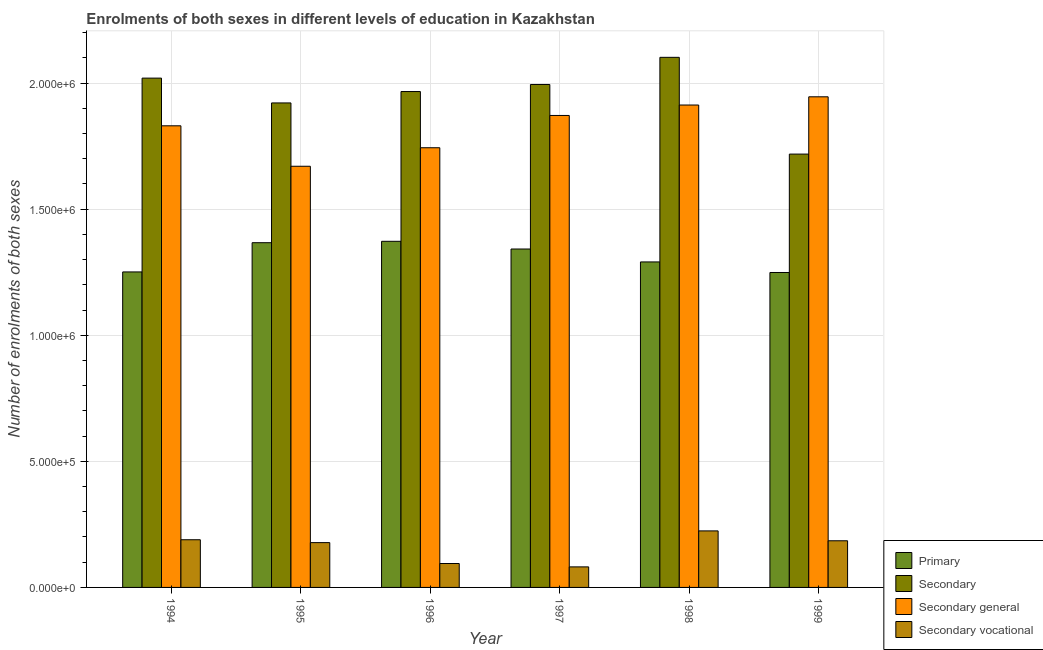How many different coloured bars are there?
Make the answer very short. 4. How many groups of bars are there?
Provide a succinct answer. 6. Are the number of bars per tick equal to the number of legend labels?
Provide a succinct answer. Yes. How many bars are there on the 6th tick from the right?
Your response must be concise. 4. What is the label of the 4th group of bars from the left?
Give a very brief answer. 1997. What is the number of enrolments in secondary general education in 1998?
Your response must be concise. 1.91e+06. Across all years, what is the maximum number of enrolments in primary education?
Provide a succinct answer. 1.37e+06. Across all years, what is the minimum number of enrolments in secondary vocational education?
Your response must be concise. 8.15e+04. What is the total number of enrolments in secondary general education in the graph?
Give a very brief answer. 1.10e+07. What is the difference between the number of enrolments in secondary education in 1994 and that in 1996?
Make the answer very short. 5.32e+04. What is the difference between the number of enrolments in secondary general education in 1998 and the number of enrolments in secondary education in 1996?
Your response must be concise. 1.69e+05. What is the average number of enrolments in secondary vocational education per year?
Your answer should be very brief. 1.59e+05. What is the ratio of the number of enrolments in secondary vocational education in 1994 to that in 1997?
Your answer should be very brief. 2.32. Is the number of enrolments in primary education in 1994 less than that in 1999?
Provide a short and direct response. No. What is the difference between the highest and the second highest number of enrolments in secondary education?
Provide a short and direct response. 8.25e+04. What is the difference between the highest and the lowest number of enrolments in primary education?
Your answer should be compact. 1.24e+05. In how many years, is the number of enrolments in secondary general education greater than the average number of enrolments in secondary general education taken over all years?
Your answer should be compact. 4. Is the sum of the number of enrolments in secondary general education in 1995 and 1998 greater than the maximum number of enrolments in primary education across all years?
Offer a very short reply. Yes. Is it the case that in every year, the sum of the number of enrolments in secondary education and number of enrolments in primary education is greater than the sum of number of enrolments in secondary vocational education and number of enrolments in secondary general education?
Provide a succinct answer. No. What does the 4th bar from the left in 1994 represents?
Your answer should be compact. Secondary vocational. What does the 3rd bar from the right in 1997 represents?
Provide a succinct answer. Secondary. Is it the case that in every year, the sum of the number of enrolments in primary education and number of enrolments in secondary education is greater than the number of enrolments in secondary general education?
Your answer should be very brief. Yes. How many bars are there?
Ensure brevity in your answer.  24. Are all the bars in the graph horizontal?
Provide a short and direct response. No. Does the graph contain any zero values?
Give a very brief answer. No. How many legend labels are there?
Provide a succinct answer. 4. How are the legend labels stacked?
Provide a short and direct response. Vertical. What is the title of the graph?
Ensure brevity in your answer.  Enrolments of both sexes in different levels of education in Kazakhstan. What is the label or title of the Y-axis?
Your answer should be compact. Number of enrolments of both sexes. What is the Number of enrolments of both sexes of Primary in 1994?
Keep it short and to the point. 1.25e+06. What is the Number of enrolments of both sexes in Secondary in 1994?
Your answer should be compact. 2.02e+06. What is the Number of enrolments of both sexes in Secondary general in 1994?
Make the answer very short. 1.83e+06. What is the Number of enrolments of both sexes of Secondary vocational in 1994?
Make the answer very short. 1.89e+05. What is the Number of enrolments of both sexes of Primary in 1995?
Make the answer very short. 1.37e+06. What is the Number of enrolments of both sexes of Secondary in 1995?
Your answer should be compact. 1.92e+06. What is the Number of enrolments of both sexes of Secondary general in 1995?
Ensure brevity in your answer.  1.67e+06. What is the Number of enrolments of both sexes in Secondary vocational in 1995?
Offer a very short reply. 1.78e+05. What is the Number of enrolments of both sexes of Primary in 1996?
Provide a succinct answer. 1.37e+06. What is the Number of enrolments of both sexes of Secondary in 1996?
Ensure brevity in your answer.  1.97e+06. What is the Number of enrolments of both sexes in Secondary general in 1996?
Provide a succinct answer. 1.74e+06. What is the Number of enrolments of both sexes in Secondary vocational in 1996?
Your answer should be very brief. 9.49e+04. What is the Number of enrolments of both sexes in Primary in 1997?
Offer a very short reply. 1.34e+06. What is the Number of enrolments of both sexes in Secondary in 1997?
Provide a succinct answer. 1.99e+06. What is the Number of enrolments of both sexes in Secondary general in 1997?
Make the answer very short. 1.87e+06. What is the Number of enrolments of both sexes of Secondary vocational in 1997?
Ensure brevity in your answer.  8.15e+04. What is the Number of enrolments of both sexes in Primary in 1998?
Provide a succinct answer. 1.29e+06. What is the Number of enrolments of both sexes in Secondary in 1998?
Provide a succinct answer. 2.10e+06. What is the Number of enrolments of both sexes in Secondary general in 1998?
Your answer should be compact. 1.91e+06. What is the Number of enrolments of both sexes of Secondary vocational in 1998?
Offer a very short reply. 2.24e+05. What is the Number of enrolments of both sexes in Primary in 1999?
Provide a succinct answer. 1.25e+06. What is the Number of enrolments of both sexes in Secondary in 1999?
Give a very brief answer. 1.72e+06. What is the Number of enrolments of both sexes in Secondary general in 1999?
Offer a very short reply. 1.95e+06. What is the Number of enrolments of both sexes of Secondary vocational in 1999?
Ensure brevity in your answer.  1.85e+05. Across all years, what is the maximum Number of enrolments of both sexes of Primary?
Make the answer very short. 1.37e+06. Across all years, what is the maximum Number of enrolments of both sexes of Secondary?
Your answer should be compact. 2.10e+06. Across all years, what is the maximum Number of enrolments of both sexes in Secondary general?
Give a very brief answer. 1.95e+06. Across all years, what is the maximum Number of enrolments of both sexes of Secondary vocational?
Keep it short and to the point. 2.24e+05. Across all years, what is the minimum Number of enrolments of both sexes in Primary?
Ensure brevity in your answer.  1.25e+06. Across all years, what is the minimum Number of enrolments of both sexes in Secondary?
Make the answer very short. 1.72e+06. Across all years, what is the minimum Number of enrolments of both sexes of Secondary general?
Provide a succinct answer. 1.67e+06. Across all years, what is the minimum Number of enrolments of both sexes of Secondary vocational?
Provide a succinct answer. 8.15e+04. What is the total Number of enrolments of both sexes of Primary in the graph?
Your response must be concise. 7.87e+06. What is the total Number of enrolments of both sexes of Secondary in the graph?
Provide a short and direct response. 1.17e+07. What is the total Number of enrolments of both sexes in Secondary general in the graph?
Your response must be concise. 1.10e+07. What is the total Number of enrolments of both sexes of Secondary vocational in the graph?
Give a very brief answer. 9.52e+05. What is the difference between the Number of enrolments of both sexes in Primary in 1994 and that in 1995?
Offer a very short reply. -1.16e+05. What is the difference between the Number of enrolments of both sexes of Secondary in 1994 and that in 1995?
Offer a terse response. 9.84e+04. What is the difference between the Number of enrolments of both sexes in Secondary general in 1994 and that in 1995?
Provide a short and direct response. 1.60e+05. What is the difference between the Number of enrolments of both sexes in Secondary vocational in 1994 and that in 1995?
Offer a very short reply. 1.14e+04. What is the difference between the Number of enrolments of both sexes of Primary in 1994 and that in 1996?
Offer a very short reply. -1.21e+05. What is the difference between the Number of enrolments of both sexes in Secondary in 1994 and that in 1996?
Give a very brief answer. 5.32e+04. What is the difference between the Number of enrolments of both sexes in Secondary general in 1994 and that in 1996?
Your answer should be very brief. 8.70e+04. What is the difference between the Number of enrolments of both sexes of Secondary vocational in 1994 and that in 1996?
Your answer should be very brief. 9.42e+04. What is the difference between the Number of enrolments of both sexes of Primary in 1994 and that in 1997?
Make the answer very short. -9.09e+04. What is the difference between the Number of enrolments of both sexes of Secondary in 1994 and that in 1997?
Give a very brief answer. 2.52e+04. What is the difference between the Number of enrolments of both sexes in Secondary general in 1994 and that in 1997?
Make the answer very short. -4.10e+04. What is the difference between the Number of enrolments of both sexes in Secondary vocational in 1994 and that in 1997?
Provide a short and direct response. 1.08e+05. What is the difference between the Number of enrolments of both sexes in Primary in 1994 and that in 1998?
Your answer should be compact. -3.97e+04. What is the difference between the Number of enrolments of both sexes in Secondary in 1994 and that in 1998?
Offer a very short reply. -8.25e+04. What is the difference between the Number of enrolments of both sexes of Secondary general in 1994 and that in 1998?
Your answer should be compact. -8.24e+04. What is the difference between the Number of enrolments of both sexes in Secondary vocational in 1994 and that in 1998?
Offer a terse response. -3.50e+04. What is the difference between the Number of enrolments of both sexes in Primary in 1994 and that in 1999?
Your response must be concise. 2211. What is the difference between the Number of enrolments of both sexes in Secondary in 1994 and that in 1999?
Keep it short and to the point. 3.01e+05. What is the difference between the Number of enrolments of both sexes in Secondary general in 1994 and that in 1999?
Keep it short and to the point. -1.15e+05. What is the difference between the Number of enrolments of both sexes in Secondary vocational in 1994 and that in 1999?
Offer a terse response. 4074. What is the difference between the Number of enrolments of both sexes of Primary in 1995 and that in 1996?
Offer a very short reply. -5534. What is the difference between the Number of enrolments of both sexes in Secondary in 1995 and that in 1996?
Offer a very short reply. -4.52e+04. What is the difference between the Number of enrolments of both sexes of Secondary general in 1995 and that in 1996?
Offer a very short reply. -7.34e+04. What is the difference between the Number of enrolments of both sexes of Secondary vocational in 1995 and that in 1996?
Your answer should be compact. 8.28e+04. What is the difference between the Number of enrolments of both sexes in Primary in 1995 and that in 1997?
Offer a terse response. 2.50e+04. What is the difference between the Number of enrolments of both sexes of Secondary in 1995 and that in 1997?
Your answer should be compact. -7.32e+04. What is the difference between the Number of enrolments of both sexes in Secondary general in 1995 and that in 1997?
Ensure brevity in your answer.  -2.01e+05. What is the difference between the Number of enrolments of both sexes of Secondary vocational in 1995 and that in 1997?
Ensure brevity in your answer.  9.62e+04. What is the difference between the Number of enrolments of both sexes of Primary in 1995 and that in 1998?
Your answer should be very brief. 7.63e+04. What is the difference between the Number of enrolments of both sexes in Secondary in 1995 and that in 1998?
Keep it short and to the point. -1.81e+05. What is the difference between the Number of enrolments of both sexes in Secondary general in 1995 and that in 1998?
Provide a succinct answer. -2.43e+05. What is the difference between the Number of enrolments of both sexes of Secondary vocational in 1995 and that in 1998?
Provide a short and direct response. -4.65e+04. What is the difference between the Number of enrolments of both sexes of Primary in 1995 and that in 1999?
Ensure brevity in your answer.  1.18e+05. What is the difference between the Number of enrolments of both sexes in Secondary in 1995 and that in 1999?
Your answer should be compact. 2.03e+05. What is the difference between the Number of enrolments of both sexes in Secondary general in 1995 and that in 1999?
Your answer should be compact. -2.75e+05. What is the difference between the Number of enrolments of both sexes in Secondary vocational in 1995 and that in 1999?
Your response must be concise. -7347. What is the difference between the Number of enrolments of both sexes of Primary in 1996 and that in 1997?
Provide a succinct answer. 3.06e+04. What is the difference between the Number of enrolments of both sexes in Secondary in 1996 and that in 1997?
Your response must be concise. -2.80e+04. What is the difference between the Number of enrolments of both sexes of Secondary general in 1996 and that in 1997?
Keep it short and to the point. -1.28e+05. What is the difference between the Number of enrolments of both sexes of Secondary vocational in 1996 and that in 1997?
Offer a very short reply. 1.34e+04. What is the difference between the Number of enrolments of both sexes in Primary in 1996 and that in 1998?
Give a very brief answer. 8.18e+04. What is the difference between the Number of enrolments of both sexes in Secondary in 1996 and that in 1998?
Provide a short and direct response. -1.36e+05. What is the difference between the Number of enrolments of both sexes of Secondary general in 1996 and that in 1998?
Keep it short and to the point. -1.69e+05. What is the difference between the Number of enrolments of both sexes of Secondary vocational in 1996 and that in 1998?
Offer a very short reply. -1.29e+05. What is the difference between the Number of enrolments of both sexes of Primary in 1996 and that in 1999?
Provide a short and direct response. 1.24e+05. What is the difference between the Number of enrolments of both sexes in Secondary in 1996 and that in 1999?
Your answer should be very brief. 2.48e+05. What is the difference between the Number of enrolments of both sexes in Secondary general in 1996 and that in 1999?
Offer a very short reply. -2.02e+05. What is the difference between the Number of enrolments of both sexes in Secondary vocational in 1996 and that in 1999?
Ensure brevity in your answer.  -9.02e+04. What is the difference between the Number of enrolments of both sexes of Primary in 1997 and that in 1998?
Provide a succinct answer. 5.12e+04. What is the difference between the Number of enrolments of both sexes of Secondary in 1997 and that in 1998?
Your response must be concise. -1.08e+05. What is the difference between the Number of enrolments of both sexes in Secondary general in 1997 and that in 1998?
Make the answer very short. -4.14e+04. What is the difference between the Number of enrolments of both sexes in Secondary vocational in 1997 and that in 1998?
Provide a short and direct response. -1.43e+05. What is the difference between the Number of enrolments of both sexes in Primary in 1997 and that in 1999?
Ensure brevity in your answer.  9.31e+04. What is the difference between the Number of enrolments of both sexes in Secondary in 1997 and that in 1999?
Keep it short and to the point. 2.76e+05. What is the difference between the Number of enrolments of both sexes of Secondary general in 1997 and that in 1999?
Your answer should be compact. -7.40e+04. What is the difference between the Number of enrolments of both sexes of Secondary vocational in 1997 and that in 1999?
Your answer should be compact. -1.04e+05. What is the difference between the Number of enrolments of both sexes of Primary in 1998 and that in 1999?
Give a very brief answer. 4.19e+04. What is the difference between the Number of enrolments of both sexes in Secondary in 1998 and that in 1999?
Make the answer very short. 3.84e+05. What is the difference between the Number of enrolments of both sexes in Secondary general in 1998 and that in 1999?
Keep it short and to the point. -3.26e+04. What is the difference between the Number of enrolments of both sexes of Secondary vocational in 1998 and that in 1999?
Offer a very short reply. 3.91e+04. What is the difference between the Number of enrolments of both sexes of Primary in 1994 and the Number of enrolments of both sexes of Secondary in 1995?
Your response must be concise. -6.70e+05. What is the difference between the Number of enrolments of both sexes in Primary in 1994 and the Number of enrolments of both sexes in Secondary general in 1995?
Make the answer very short. -4.19e+05. What is the difference between the Number of enrolments of both sexes in Primary in 1994 and the Number of enrolments of both sexes in Secondary vocational in 1995?
Your answer should be very brief. 1.07e+06. What is the difference between the Number of enrolments of both sexes of Secondary in 1994 and the Number of enrolments of both sexes of Secondary general in 1995?
Provide a succinct answer. 3.50e+05. What is the difference between the Number of enrolments of both sexes in Secondary in 1994 and the Number of enrolments of both sexes in Secondary vocational in 1995?
Offer a very short reply. 1.84e+06. What is the difference between the Number of enrolments of both sexes in Secondary general in 1994 and the Number of enrolments of both sexes in Secondary vocational in 1995?
Offer a very short reply. 1.65e+06. What is the difference between the Number of enrolments of both sexes of Primary in 1994 and the Number of enrolments of both sexes of Secondary in 1996?
Your answer should be very brief. -7.15e+05. What is the difference between the Number of enrolments of both sexes in Primary in 1994 and the Number of enrolments of both sexes in Secondary general in 1996?
Offer a very short reply. -4.93e+05. What is the difference between the Number of enrolments of both sexes in Primary in 1994 and the Number of enrolments of both sexes in Secondary vocational in 1996?
Give a very brief answer. 1.16e+06. What is the difference between the Number of enrolments of both sexes of Secondary in 1994 and the Number of enrolments of both sexes of Secondary general in 1996?
Offer a terse response. 2.76e+05. What is the difference between the Number of enrolments of both sexes of Secondary in 1994 and the Number of enrolments of both sexes of Secondary vocational in 1996?
Your response must be concise. 1.92e+06. What is the difference between the Number of enrolments of both sexes of Secondary general in 1994 and the Number of enrolments of both sexes of Secondary vocational in 1996?
Give a very brief answer. 1.74e+06. What is the difference between the Number of enrolments of both sexes of Primary in 1994 and the Number of enrolments of both sexes of Secondary in 1997?
Make the answer very short. -7.43e+05. What is the difference between the Number of enrolments of both sexes of Primary in 1994 and the Number of enrolments of both sexes of Secondary general in 1997?
Offer a very short reply. -6.20e+05. What is the difference between the Number of enrolments of both sexes in Primary in 1994 and the Number of enrolments of both sexes in Secondary vocational in 1997?
Your answer should be very brief. 1.17e+06. What is the difference between the Number of enrolments of both sexes in Secondary in 1994 and the Number of enrolments of both sexes in Secondary general in 1997?
Keep it short and to the point. 1.48e+05. What is the difference between the Number of enrolments of both sexes of Secondary in 1994 and the Number of enrolments of both sexes of Secondary vocational in 1997?
Your answer should be compact. 1.94e+06. What is the difference between the Number of enrolments of both sexes of Secondary general in 1994 and the Number of enrolments of both sexes of Secondary vocational in 1997?
Ensure brevity in your answer.  1.75e+06. What is the difference between the Number of enrolments of both sexes of Primary in 1994 and the Number of enrolments of both sexes of Secondary in 1998?
Your response must be concise. -8.51e+05. What is the difference between the Number of enrolments of both sexes in Primary in 1994 and the Number of enrolments of both sexes in Secondary general in 1998?
Your answer should be very brief. -6.62e+05. What is the difference between the Number of enrolments of both sexes in Primary in 1994 and the Number of enrolments of both sexes in Secondary vocational in 1998?
Provide a short and direct response. 1.03e+06. What is the difference between the Number of enrolments of both sexes of Secondary in 1994 and the Number of enrolments of both sexes of Secondary general in 1998?
Make the answer very short. 1.07e+05. What is the difference between the Number of enrolments of both sexes in Secondary in 1994 and the Number of enrolments of both sexes in Secondary vocational in 1998?
Your answer should be very brief. 1.80e+06. What is the difference between the Number of enrolments of both sexes of Secondary general in 1994 and the Number of enrolments of both sexes of Secondary vocational in 1998?
Provide a succinct answer. 1.61e+06. What is the difference between the Number of enrolments of both sexes in Primary in 1994 and the Number of enrolments of both sexes in Secondary in 1999?
Your answer should be very brief. -4.67e+05. What is the difference between the Number of enrolments of both sexes in Primary in 1994 and the Number of enrolments of both sexes in Secondary general in 1999?
Provide a succinct answer. -6.94e+05. What is the difference between the Number of enrolments of both sexes in Primary in 1994 and the Number of enrolments of both sexes in Secondary vocational in 1999?
Make the answer very short. 1.07e+06. What is the difference between the Number of enrolments of both sexes in Secondary in 1994 and the Number of enrolments of both sexes in Secondary general in 1999?
Offer a terse response. 7.41e+04. What is the difference between the Number of enrolments of both sexes in Secondary in 1994 and the Number of enrolments of both sexes in Secondary vocational in 1999?
Your answer should be compact. 1.83e+06. What is the difference between the Number of enrolments of both sexes in Secondary general in 1994 and the Number of enrolments of both sexes in Secondary vocational in 1999?
Your answer should be compact. 1.65e+06. What is the difference between the Number of enrolments of both sexes in Primary in 1995 and the Number of enrolments of both sexes in Secondary in 1996?
Ensure brevity in your answer.  -5.99e+05. What is the difference between the Number of enrolments of both sexes of Primary in 1995 and the Number of enrolments of both sexes of Secondary general in 1996?
Provide a short and direct response. -3.77e+05. What is the difference between the Number of enrolments of both sexes of Primary in 1995 and the Number of enrolments of both sexes of Secondary vocational in 1996?
Give a very brief answer. 1.27e+06. What is the difference between the Number of enrolments of both sexes in Secondary in 1995 and the Number of enrolments of both sexes in Secondary general in 1996?
Ensure brevity in your answer.  1.78e+05. What is the difference between the Number of enrolments of both sexes in Secondary in 1995 and the Number of enrolments of both sexes in Secondary vocational in 1996?
Keep it short and to the point. 1.83e+06. What is the difference between the Number of enrolments of both sexes in Secondary general in 1995 and the Number of enrolments of both sexes in Secondary vocational in 1996?
Your answer should be very brief. 1.58e+06. What is the difference between the Number of enrolments of both sexes in Primary in 1995 and the Number of enrolments of both sexes in Secondary in 1997?
Your answer should be compact. -6.27e+05. What is the difference between the Number of enrolments of both sexes of Primary in 1995 and the Number of enrolments of both sexes of Secondary general in 1997?
Your answer should be compact. -5.05e+05. What is the difference between the Number of enrolments of both sexes in Primary in 1995 and the Number of enrolments of both sexes in Secondary vocational in 1997?
Provide a succinct answer. 1.29e+06. What is the difference between the Number of enrolments of both sexes of Secondary in 1995 and the Number of enrolments of both sexes of Secondary general in 1997?
Your response must be concise. 4.97e+04. What is the difference between the Number of enrolments of both sexes of Secondary in 1995 and the Number of enrolments of both sexes of Secondary vocational in 1997?
Offer a very short reply. 1.84e+06. What is the difference between the Number of enrolments of both sexes in Secondary general in 1995 and the Number of enrolments of both sexes in Secondary vocational in 1997?
Provide a succinct answer. 1.59e+06. What is the difference between the Number of enrolments of both sexes in Primary in 1995 and the Number of enrolments of both sexes in Secondary in 1998?
Offer a terse response. -7.35e+05. What is the difference between the Number of enrolments of both sexes in Primary in 1995 and the Number of enrolments of both sexes in Secondary general in 1998?
Provide a short and direct response. -5.46e+05. What is the difference between the Number of enrolments of both sexes in Primary in 1995 and the Number of enrolments of both sexes in Secondary vocational in 1998?
Ensure brevity in your answer.  1.14e+06. What is the difference between the Number of enrolments of both sexes of Secondary in 1995 and the Number of enrolments of both sexes of Secondary general in 1998?
Offer a very short reply. 8285. What is the difference between the Number of enrolments of both sexes in Secondary in 1995 and the Number of enrolments of both sexes in Secondary vocational in 1998?
Provide a short and direct response. 1.70e+06. What is the difference between the Number of enrolments of both sexes in Secondary general in 1995 and the Number of enrolments of both sexes in Secondary vocational in 1998?
Offer a terse response. 1.45e+06. What is the difference between the Number of enrolments of both sexes of Primary in 1995 and the Number of enrolments of both sexes of Secondary in 1999?
Your answer should be very brief. -3.51e+05. What is the difference between the Number of enrolments of both sexes in Primary in 1995 and the Number of enrolments of both sexes in Secondary general in 1999?
Provide a succinct answer. -5.79e+05. What is the difference between the Number of enrolments of both sexes in Primary in 1995 and the Number of enrolments of both sexes in Secondary vocational in 1999?
Give a very brief answer. 1.18e+06. What is the difference between the Number of enrolments of both sexes in Secondary in 1995 and the Number of enrolments of both sexes in Secondary general in 1999?
Offer a terse response. -2.43e+04. What is the difference between the Number of enrolments of both sexes in Secondary in 1995 and the Number of enrolments of both sexes in Secondary vocational in 1999?
Your response must be concise. 1.74e+06. What is the difference between the Number of enrolments of both sexes in Secondary general in 1995 and the Number of enrolments of both sexes in Secondary vocational in 1999?
Give a very brief answer. 1.49e+06. What is the difference between the Number of enrolments of both sexes in Primary in 1996 and the Number of enrolments of both sexes in Secondary in 1997?
Your answer should be very brief. -6.22e+05. What is the difference between the Number of enrolments of both sexes in Primary in 1996 and the Number of enrolments of both sexes in Secondary general in 1997?
Give a very brief answer. -4.99e+05. What is the difference between the Number of enrolments of both sexes of Primary in 1996 and the Number of enrolments of both sexes of Secondary vocational in 1997?
Keep it short and to the point. 1.29e+06. What is the difference between the Number of enrolments of both sexes of Secondary in 1996 and the Number of enrolments of both sexes of Secondary general in 1997?
Offer a very short reply. 9.49e+04. What is the difference between the Number of enrolments of both sexes in Secondary in 1996 and the Number of enrolments of both sexes in Secondary vocational in 1997?
Your answer should be compact. 1.88e+06. What is the difference between the Number of enrolments of both sexes of Secondary general in 1996 and the Number of enrolments of both sexes of Secondary vocational in 1997?
Provide a succinct answer. 1.66e+06. What is the difference between the Number of enrolments of both sexes in Primary in 1996 and the Number of enrolments of both sexes in Secondary in 1998?
Provide a short and direct response. -7.30e+05. What is the difference between the Number of enrolments of both sexes of Primary in 1996 and the Number of enrolments of both sexes of Secondary general in 1998?
Offer a very short reply. -5.40e+05. What is the difference between the Number of enrolments of both sexes in Primary in 1996 and the Number of enrolments of both sexes in Secondary vocational in 1998?
Keep it short and to the point. 1.15e+06. What is the difference between the Number of enrolments of both sexes of Secondary in 1996 and the Number of enrolments of both sexes of Secondary general in 1998?
Offer a terse response. 5.35e+04. What is the difference between the Number of enrolments of both sexes in Secondary in 1996 and the Number of enrolments of both sexes in Secondary vocational in 1998?
Make the answer very short. 1.74e+06. What is the difference between the Number of enrolments of both sexes of Secondary general in 1996 and the Number of enrolments of both sexes of Secondary vocational in 1998?
Provide a short and direct response. 1.52e+06. What is the difference between the Number of enrolments of both sexes in Primary in 1996 and the Number of enrolments of both sexes in Secondary in 1999?
Provide a short and direct response. -3.46e+05. What is the difference between the Number of enrolments of both sexes in Primary in 1996 and the Number of enrolments of both sexes in Secondary general in 1999?
Offer a terse response. -5.73e+05. What is the difference between the Number of enrolments of both sexes of Primary in 1996 and the Number of enrolments of both sexes of Secondary vocational in 1999?
Offer a very short reply. 1.19e+06. What is the difference between the Number of enrolments of both sexes of Secondary in 1996 and the Number of enrolments of both sexes of Secondary general in 1999?
Your response must be concise. 2.09e+04. What is the difference between the Number of enrolments of both sexes of Secondary in 1996 and the Number of enrolments of both sexes of Secondary vocational in 1999?
Provide a short and direct response. 1.78e+06. What is the difference between the Number of enrolments of both sexes in Secondary general in 1996 and the Number of enrolments of both sexes in Secondary vocational in 1999?
Make the answer very short. 1.56e+06. What is the difference between the Number of enrolments of both sexes of Primary in 1997 and the Number of enrolments of both sexes of Secondary in 1998?
Your answer should be compact. -7.60e+05. What is the difference between the Number of enrolments of both sexes of Primary in 1997 and the Number of enrolments of both sexes of Secondary general in 1998?
Your response must be concise. -5.71e+05. What is the difference between the Number of enrolments of both sexes of Primary in 1997 and the Number of enrolments of both sexes of Secondary vocational in 1998?
Offer a terse response. 1.12e+06. What is the difference between the Number of enrolments of both sexes in Secondary in 1997 and the Number of enrolments of both sexes in Secondary general in 1998?
Give a very brief answer. 8.15e+04. What is the difference between the Number of enrolments of both sexes of Secondary in 1997 and the Number of enrolments of both sexes of Secondary vocational in 1998?
Your answer should be very brief. 1.77e+06. What is the difference between the Number of enrolments of both sexes of Secondary general in 1997 and the Number of enrolments of both sexes of Secondary vocational in 1998?
Your response must be concise. 1.65e+06. What is the difference between the Number of enrolments of both sexes in Primary in 1997 and the Number of enrolments of both sexes in Secondary in 1999?
Offer a terse response. -3.76e+05. What is the difference between the Number of enrolments of both sexes of Primary in 1997 and the Number of enrolments of both sexes of Secondary general in 1999?
Make the answer very short. -6.04e+05. What is the difference between the Number of enrolments of both sexes in Primary in 1997 and the Number of enrolments of both sexes in Secondary vocational in 1999?
Your answer should be compact. 1.16e+06. What is the difference between the Number of enrolments of both sexes in Secondary in 1997 and the Number of enrolments of both sexes in Secondary general in 1999?
Keep it short and to the point. 4.89e+04. What is the difference between the Number of enrolments of both sexes in Secondary in 1997 and the Number of enrolments of both sexes in Secondary vocational in 1999?
Offer a terse response. 1.81e+06. What is the difference between the Number of enrolments of both sexes in Secondary general in 1997 and the Number of enrolments of both sexes in Secondary vocational in 1999?
Provide a short and direct response. 1.69e+06. What is the difference between the Number of enrolments of both sexes in Primary in 1998 and the Number of enrolments of both sexes in Secondary in 1999?
Keep it short and to the point. -4.28e+05. What is the difference between the Number of enrolments of both sexes in Primary in 1998 and the Number of enrolments of both sexes in Secondary general in 1999?
Your answer should be compact. -6.55e+05. What is the difference between the Number of enrolments of both sexes in Primary in 1998 and the Number of enrolments of both sexes in Secondary vocational in 1999?
Your answer should be compact. 1.11e+06. What is the difference between the Number of enrolments of both sexes in Secondary in 1998 and the Number of enrolments of both sexes in Secondary general in 1999?
Your response must be concise. 1.57e+05. What is the difference between the Number of enrolments of both sexes in Secondary in 1998 and the Number of enrolments of both sexes in Secondary vocational in 1999?
Give a very brief answer. 1.92e+06. What is the difference between the Number of enrolments of both sexes in Secondary general in 1998 and the Number of enrolments of both sexes in Secondary vocational in 1999?
Keep it short and to the point. 1.73e+06. What is the average Number of enrolments of both sexes in Primary per year?
Offer a very short reply. 1.31e+06. What is the average Number of enrolments of both sexes of Secondary per year?
Your answer should be very brief. 1.95e+06. What is the average Number of enrolments of both sexes of Secondary general per year?
Provide a short and direct response. 1.83e+06. What is the average Number of enrolments of both sexes of Secondary vocational per year?
Your response must be concise. 1.59e+05. In the year 1994, what is the difference between the Number of enrolments of both sexes in Primary and Number of enrolments of both sexes in Secondary?
Ensure brevity in your answer.  -7.69e+05. In the year 1994, what is the difference between the Number of enrolments of both sexes in Primary and Number of enrolments of both sexes in Secondary general?
Offer a terse response. -5.79e+05. In the year 1994, what is the difference between the Number of enrolments of both sexes of Primary and Number of enrolments of both sexes of Secondary vocational?
Provide a short and direct response. 1.06e+06. In the year 1994, what is the difference between the Number of enrolments of both sexes in Secondary and Number of enrolments of both sexes in Secondary general?
Provide a short and direct response. 1.89e+05. In the year 1994, what is the difference between the Number of enrolments of both sexes of Secondary and Number of enrolments of both sexes of Secondary vocational?
Offer a very short reply. 1.83e+06. In the year 1994, what is the difference between the Number of enrolments of both sexes in Secondary general and Number of enrolments of both sexes in Secondary vocational?
Provide a short and direct response. 1.64e+06. In the year 1995, what is the difference between the Number of enrolments of both sexes in Primary and Number of enrolments of both sexes in Secondary?
Your answer should be very brief. -5.54e+05. In the year 1995, what is the difference between the Number of enrolments of both sexes of Primary and Number of enrolments of both sexes of Secondary general?
Make the answer very short. -3.03e+05. In the year 1995, what is the difference between the Number of enrolments of both sexes of Primary and Number of enrolments of both sexes of Secondary vocational?
Provide a short and direct response. 1.19e+06. In the year 1995, what is the difference between the Number of enrolments of both sexes in Secondary and Number of enrolments of both sexes in Secondary general?
Offer a terse response. 2.51e+05. In the year 1995, what is the difference between the Number of enrolments of both sexes in Secondary and Number of enrolments of both sexes in Secondary vocational?
Your answer should be compact. 1.74e+06. In the year 1995, what is the difference between the Number of enrolments of both sexes in Secondary general and Number of enrolments of both sexes in Secondary vocational?
Provide a succinct answer. 1.49e+06. In the year 1996, what is the difference between the Number of enrolments of both sexes in Primary and Number of enrolments of both sexes in Secondary?
Provide a short and direct response. -5.94e+05. In the year 1996, what is the difference between the Number of enrolments of both sexes of Primary and Number of enrolments of both sexes of Secondary general?
Your answer should be very brief. -3.71e+05. In the year 1996, what is the difference between the Number of enrolments of both sexes of Primary and Number of enrolments of both sexes of Secondary vocational?
Your response must be concise. 1.28e+06. In the year 1996, what is the difference between the Number of enrolments of both sexes in Secondary and Number of enrolments of both sexes in Secondary general?
Your answer should be very brief. 2.23e+05. In the year 1996, what is the difference between the Number of enrolments of both sexes of Secondary and Number of enrolments of both sexes of Secondary vocational?
Your answer should be very brief. 1.87e+06. In the year 1996, what is the difference between the Number of enrolments of both sexes of Secondary general and Number of enrolments of both sexes of Secondary vocational?
Your answer should be compact. 1.65e+06. In the year 1997, what is the difference between the Number of enrolments of both sexes in Primary and Number of enrolments of both sexes in Secondary?
Make the answer very short. -6.52e+05. In the year 1997, what is the difference between the Number of enrolments of both sexes of Primary and Number of enrolments of both sexes of Secondary general?
Your answer should be very brief. -5.30e+05. In the year 1997, what is the difference between the Number of enrolments of both sexes in Primary and Number of enrolments of both sexes in Secondary vocational?
Make the answer very short. 1.26e+06. In the year 1997, what is the difference between the Number of enrolments of both sexes in Secondary and Number of enrolments of both sexes in Secondary general?
Ensure brevity in your answer.  1.23e+05. In the year 1997, what is the difference between the Number of enrolments of both sexes of Secondary and Number of enrolments of both sexes of Secondary vocational?
Provide a succinct answer. 1.91e+06. In the year 1997, what is the difference between the Number of enrolments of both sexes of Secondary general and Number of enrolments of both sexes of Secondary vocational?
Provide a succinct answer. 1.79e+06. In the year 1998, what is the difference between the Number of enrolments of both sexes in Primary and Number of enrolments of both sexes in Secondary?
Keep it short and to the point. -8.11e+05. In the year 1998, what is the difference between the Number of enrolments of both sexes in Primary and Number of enrolments of both sexes in Secondary general?
Offer a very short reply. -6.22e+05. In the year 1998, what is the difference between the Number of enrolments of both sexes in Primary and Number of enrolments of both sexes in Secondary vocational?
Your answer should be compact. 1.07e+06. In the year 1998, what is the difference between the Number of enrolments of both sexes in Secondary and Number of enrolments of both sexes in Secondary general?
Give a very brief answer. 1.89e+05. In the year 1998, what is the difference between the Number of enrolments of both sexes of Secondary and Number of enrolments of both sexes of Secondary vocational?
Provide a short and direct response. 1.88e+06. In the year 1998, what is the difference between the Number of enrolments of both sexes of Secondary general and Number of enrolments of both sexes of Secondary vocational?
Provide a succinct answer. 1.69e+06. In the year 1999, what is the difference between the Number of enrolments of both sexes of Primary and Number of enrolments of both sexes of Secondary?
Your answer should be very brief. -4.70e+05. In the year 1999, what is the difference between the Number of enrolments of both sexes in Primary and Number of enrolments of both sexes in Secondary general?
Make the answer very short. -6.97e+05. In the year 1999, what is the difference between the Number of enrolments of both sexes of Primary and Number of enrolments of both sexes of Secondary vocational?
Offer a very short reply. 1.06e+06. In the year 1999, what is the difference between the Number of enrolments of both sexes in Secondary and Number of enrolments of both sexes in Secondary general?
Keep it short and to the point. -2.27e+05. In the year 1999, what is the difference between the Number of enrolments of both sexes in Secondary and Number of enrolments of both sexes in Secondary vocational?
Your answer should be compact. 1.53e+06. In the year 1999, what is the difference between the Number of enrolments of both sexes of Secondary general and Number of enrolments of both sexes of Secondary vocational?
Your response must be concise. 1.76e+06. What is the ratio of the Number of enrolments of both sexes in Primary in 1994 to that in 1995?
Your answer should be compact. 0.92. What is the ratio of the Number of enrolments of both sexes in Secondary in 1994 to that in 1995?
Offer a terse response. 1.05. What is the ratio of the Number of enrolments of both sexes in Secondary general in 1994 to that in 1995?
Keep it short and to the point. 1.1. What is the ratio of the Number of enrolments of both sexes of Secondary vocational in 1994 to that in 1995?
Give a very brief answer. 1.06. What is the ratio of the Number of enrolments of both sexes of Primary in 1994 to that in 1996?
Offer a terse response. 0.91. What is the ratio of the Number of enrolments of both sexes in Secondary in 1994 to that in 1996?
Ensure brevity in your answer.  1.03. What is the ratio of the Number of enrolments of both sexes of Secondary general in 1994 to that in 1996?
Your answer should be very brief. 1.05. What is the ratio of the Number of enrolments of both sexes in Secondary vocational in 1994 to that in 1996?
Give a very brief answer. 1.99. What is the ratio of the Number of enrolments of both sexes in Primary in 1994 to that in 1997?
Keep it short and to the point. 0.93. What is the ratio of the Number of enrolments of both sexes in Secondary in 1994 to that in 1997?
Your answer should be compact. 1.01. What is the ratio of the Number of enrolments of both sexes in Secondary general in 1994 to that in 1997?
Offer a terse response. 0.98. What is the ratio of the Number of enrolments of both sexes of Secondary vocational in 1994 to that in 1997?
Your answer should be very brief. 2.32. What is the ratio of the Number of enrolments of both sexes of Primary in 1994 to that in 1998?
Keep it short and to the point. 0.97. What is the ratio of the Number of enrolments of both sexes of Secondary in 1994 to that in 1998?
Your response must be concise. 0.96. What is the ratio of the Number of enrolments of both sexes of Secondary general in 1994 to that in 1998?
Provide a succinct answer. 0.96. What is the ratio of the Number of enrolments of both sexes in Secondary vocational in 1994 to that in 1998?
Offer a very short reply. 0.84. What is the ratio of the Number of enrolments of both sexes of Secondary in 1994 to that in 1999?
Offer a terse response. 1.18. What is the ratio of the Number of enrolments of both sexes of Secondary general in 1994 to that in 1999?
Provide a short and direct response. 0.94. What is the ratio of the Number of enrolments of both sexes in Primary in 1995 to that in 1996?
Offer a very short reply. 1. What is the ratio of the Number of enrolments of both sexes in Secondary general in 1995 to that in 1996?
Offer a very short reply. 0.96. What is the ratio of the Number of enrolments of both sexes of Secondary vocational in 1995 to that in 1996?
Offer a very short reply. 1.87. What is the ratio of the Number of enrolments of both sexes in Primary in 1995 to that in 1997?
Your response must be concise. 1.02. What is the ratio of the Number of enrolments of both sexes in Secondary in 1995 to that in 1997?
Make the answer very short. 0.96. What is the ratio of the Number of enrolments of both sexes of Secondary general in 1995 to that in 1997?
Ensure brevity in your answer.  0.89. What is the ratio of the Number of enrolments of both sexes of Secondary vocational in 1995 to that in 1997?
Keep it short and to the point. 2.18. What is the ratio of the Number of enrolments of both sexes of Primary in 1995 to that in 1998?
Make the answer very short. 1.06. What is the ratio of the Number of enrolments of both sexes in Secondary in 1995 to that in 1998?
Your answer should be compact. 0.91. What is the ratio of the Number of enrolments of both sexes of Secondary general in 1995 to that in 1998?
Provide a succinct answer. 0.87. What is the ratio of the Number of enrolments of both sexes of Secondary vocational in 1995 to that in 1998?
Your answer should be compact. 0.79. What is the ratio of the Number of enrolments of both sexes in Primary in 1995 to that in 1999?
Your answer should be very brief. 1.09. What is the ratio of the Number of enrolments of both sexes of Secondary in 1995 to that in 1999?
Give a very brief answer. 1.12. What is the ratio of the Number of enrolments of both sexes in Secondary general in 1995 to that in 1999?
Your response must be concise. 0.86. What is the ratio of the Number of enrolments of both sexes of Secondary vocational in 1995 to that in 1999?
Offer a very short reply. 0.96. What is the ratio of the Number of enrolments of both sexes in Primary in 1996 to that in 1997?
Your answer should be very brief. 1.02. What is the ratio of the Number of enrolments of both sexes of Secondary general in 1996 to that in 1997?
Give a very brief answer. 0.93. What is the ratio of the Number of enrolments of both sexes in Secondary vocational in 1996 to that in 1997?
Your answer should be very brief. 1.16. What is the ratio of the Number of enrolments of both sexes of Primary in 1996 to that in 1998?
Ensure brevity in your answer.  1.06. What is the ratio of the Number of enrolments of both sexes of Secondary in 1996 to that in 1998?
Your answer should be very brief. 0.94. What is the ratio of the Number of enrolments of both sexes of Secondary general in 1996 to that in 1998?
Offer a terse response. 0.91. What is the ratio of the Number of enrolments of both sexes in Secondary vocational in 1996 to that in 1998?
Offer a terse response. 0.42. What is the ratio of the Number of enrolments of both sexes of Primary in 1996 to that in 1999?
Ensure brevity in your answer.  1.1. What is the ratio of the Number of enrolments of both sexes of Secondary in 1996 to that in 1999?
Provide a short and direct response. 1.14. What is the ratio of the Number of enrolments of both sexes of Secondary general in 1996 to that in 1999?
Offer a very short reply. 0.9. What is the ratio of the Number of enrolments of both sexes in Secondary vocational in 1996 to that in 1999?
Keep it short and to the point. 0.51. What is the ratio of the Number of enrolments of both sexes in Primary in 1997 to that in 1998?
Your response must be concise. 1.04. What is the ratio of the Number of enrolments of both sexes of Secondary in 1997 to that in 1998?
Keep it short and to the point. 0.95. What is the ratio of the Number of enrolments of both sexes of Secondary general in 1997 to that in 1998?
Provide a succinct answer. 0.98. What is the ratio of the Number of enrolments of both sexes of Secondary vocational in 1997 to that in 1998?
Make the answer very short. 0.36. What is the ratio of the Number of enrolments of both sexes of Primary in 1997 to that in 1999?
Make the answer very short. 1.07. What is the ratio of the Number of enrolments of both sexes of Secondary in 1997 to that in 1999?
Offer a very short reply. 1.16. What is the ratio of the Number of enrolments of both sexes in Secondary general in 1997 to that in 1999?
Provide a short and direct response. 0.96. What is the ratio of the Number of enrolments of both sexes in Secondary vocational in 1997 to that in 1999?
Make the answer very short. 0.44. What is the ratio of the Number of enrolments of both sexes of Primary in 1998 to that in 1999?
Offer a very short reply. 1.03. What is the ratio of the Number of enrolments of both sexes of Secondary in 1998 to that in 1999?
Make the answer very short. 1.22. What is the ratio of the Number of enrolments of both sexes in Secondary general in 1998 to that in 1999?
Give a very brief answer. 0.98. What is the ratio of the Number of enrolments of both sexes of Secondary vocational in 1998 to that in 1999?
Keep it short and to the point. 1.21. What is the difference between the highest and the second highest Number of enrolments of both sexes of Primary?
Ensure brevity in your answer.  5534. What is the difference between the highest and the second highest Number of enrolments of both sexes in Secondary?
Give a very brief answer. 8.25e+04. What is the difference between the highest and the second highest Number of enrolments of both sexes in Secondary general?
Provide a succinct answer. 3.26e+04. What is the difference between the highest and the second highest Number of enrolments of both sexes in Secondary vocational?
Provide a succinct answer. 3.50e+04. What is the difference between the highest and the lowest Number of enrolments of both sexes in Primary?
Give a very brief answer. 1.24e+05. What is the difference between the highest and the lowest Number of enrolments of both sexes in Secondary?
Ensure brevity in your answer.  3.84e+05. What is the difference between the highest and the lowest Number of enrolments of both sexes in Secondary general?
Make the answer very short. 2.75e+05. What is the difference between the highest and the lowest Number of enrolments of both sexes in Secondary vocational?
Provide a short and direct response. 1.43e+05. 